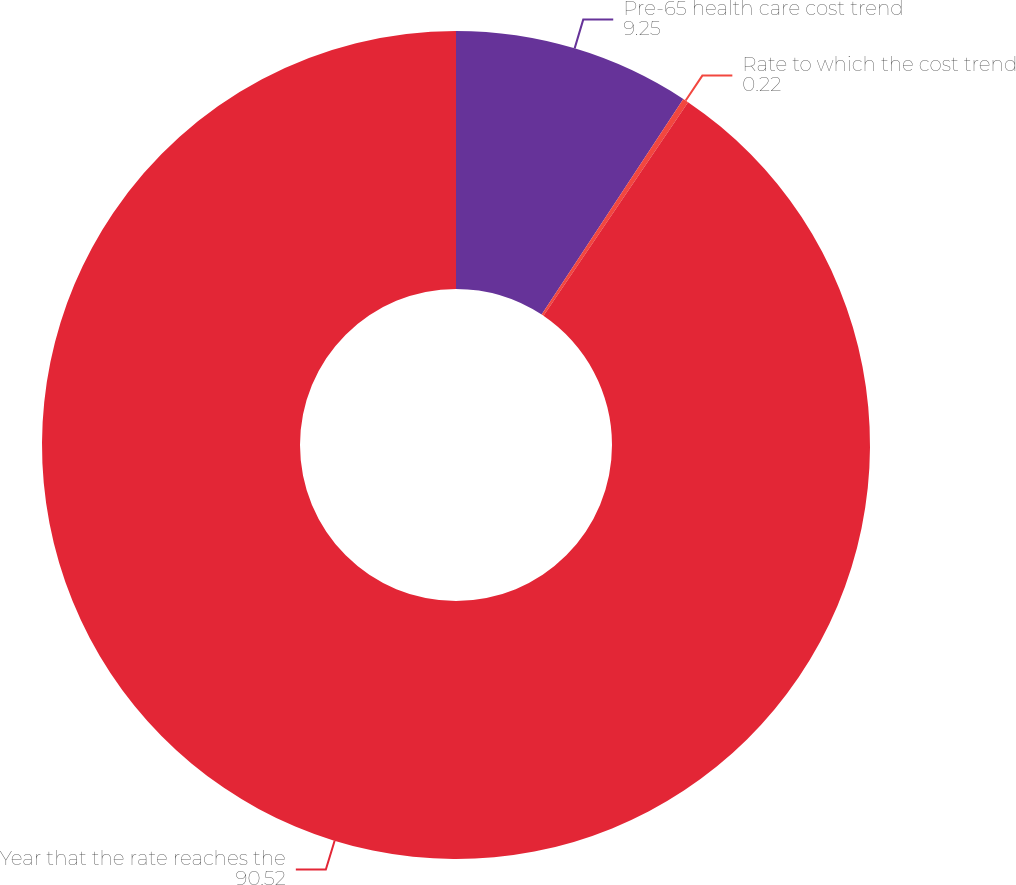Convert chart. <chart><loc_0><loc_0><loc_500><loc_500><pie_chart><fcel>Pre-65 health care cost trend<fcel>Rate to which the cost trend<fcel>Year that the rate reaches the<nl><fcel>9.25%<fcel>0.22%<fcel>90.52%<nl></chart> 